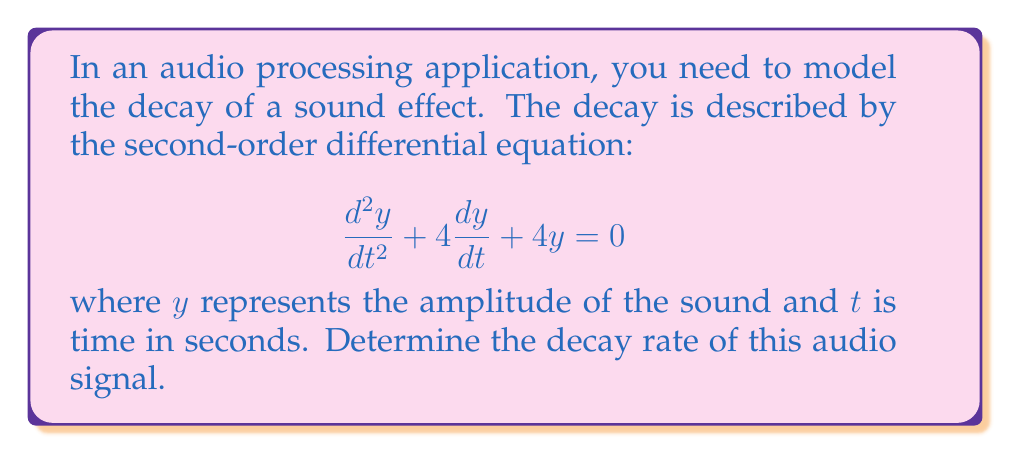Give your solution to this math problem. To solve this problem, we'll follow these steps:

1) The characteristic equation for this second-order differential equation is:
   $$r^2 + 4r + 4 = 0$$

2) We can solve this using the quadratic formula: $r = \frac{-b \pm \sqrt{b^2 - 4ac}}{2a}$
   
   Here, $a=1$, $b=4$, and $c=4$

3) Substituting these values:
   $$r = \frac{-4 \pm \sqrt{4^2 - 4(1)(4)}}{2(1)} = \frac{-4 \pm \sqrt{16 - 16}}{2} = \frac{-4 \pm 0}{2} = -2$$

4) This means we have a repeated root $r = -2$

5) The general solution for a second-order differential equation with a repeated root is:
   $$y = (C_1 + C_2t)e^{rt}$$
   
   Where $C_1$ and $C_2$ are constants determined by initial conditions.

6) Substituting our value of $r$:
   $$y = (C_1 + C_2t)e^{-2t}$$

7) The decay rate is determined by the exponent of $e$. In this case, it's $-2$.

Therefore, the decay rate of the audio signal is 2 per second.
Answer: The decay rate of the audio signal is 2 per second. 